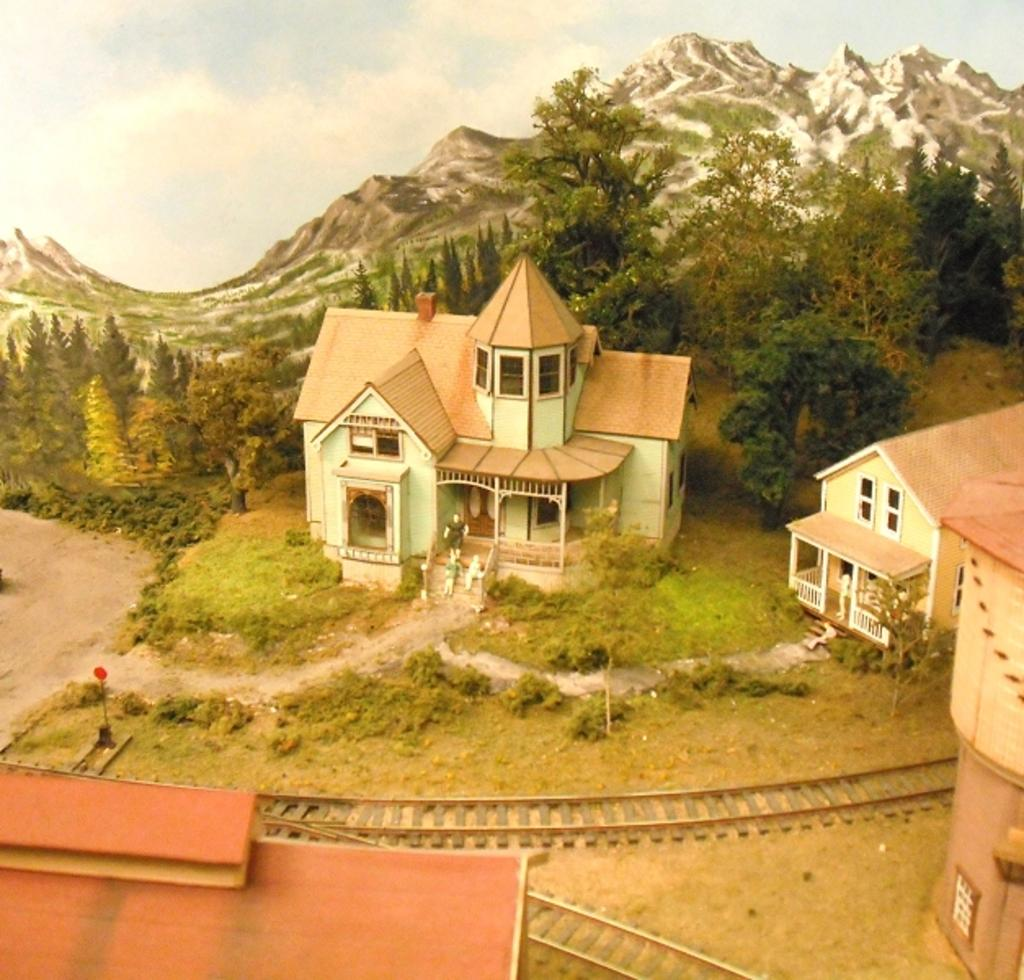What type of structures can be seen in the image? There are houses in the image. What else is visible in the image besides the houses? There are tracks, trees, and hills in the image. Can you describe the people in the image? There are people in front of a house in the image. How many tickets are visible in the image? There are no tickets present in the image. Can you see any ducks in the image? There are no ducks present in the image. 